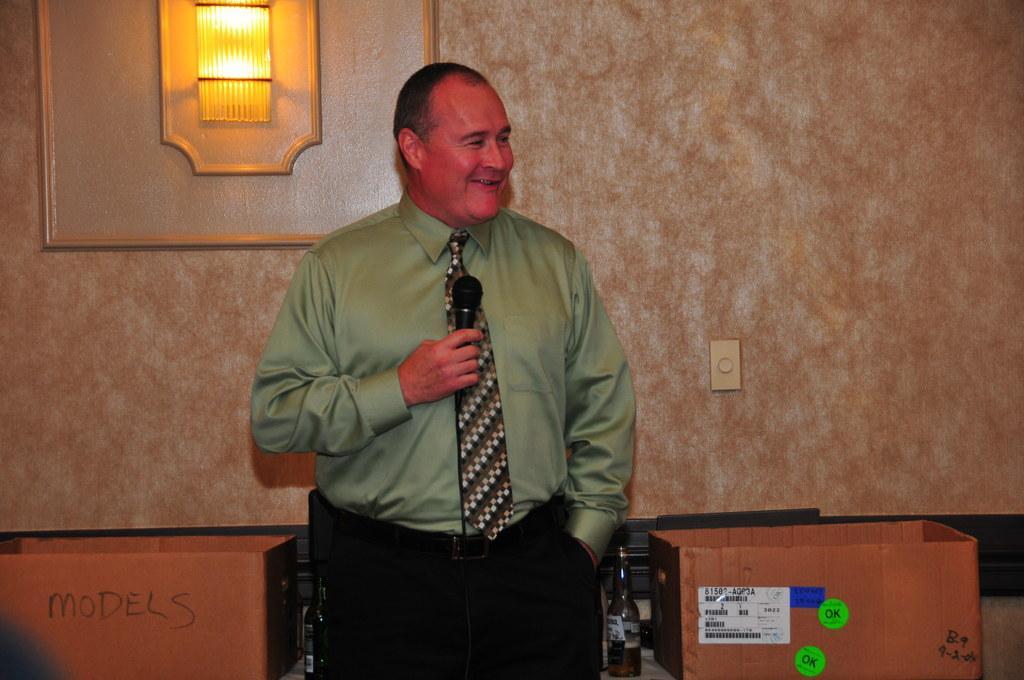Could you give a brief overview of what you see in this image? In this image there is a man holding a mic and smiling. He is wearing a green shirt and black pant. Beside him there are boxes. In the background, there is a wall on which a frame along with light is fixed. 